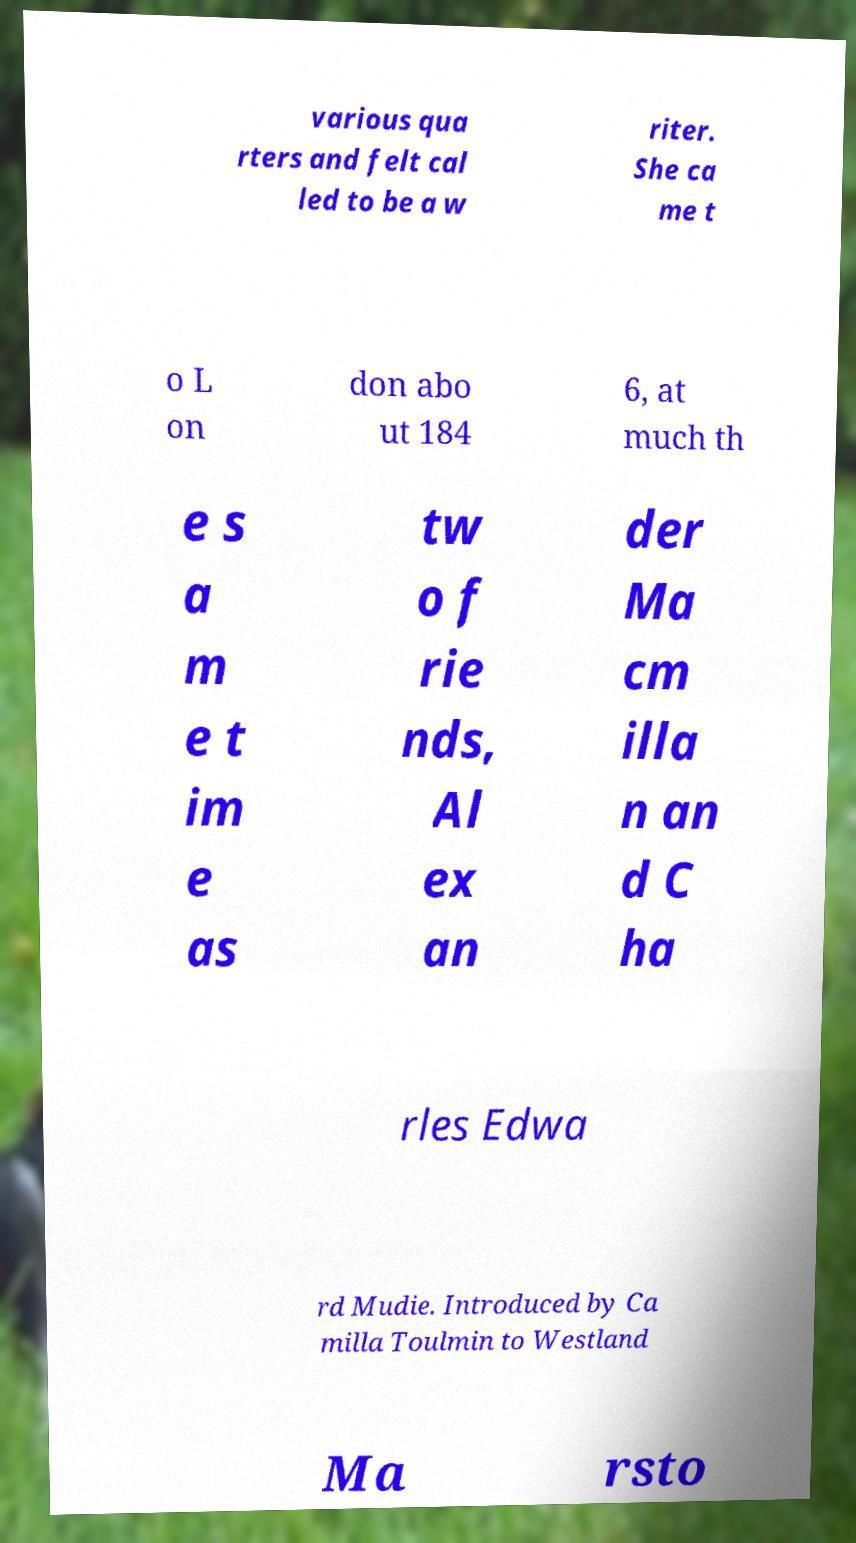Could you extract and type out the text from this image? various qua rters and felt cal led to be a w riter. She ca me t o L on don abo ut 184 6, at much th e s a m e t im e as tw o f rie nds, Al ex an der Ma cm illa n an d C ha rles Edwa rd Mudie. Introduced by Ca milla Toulmin to Westland Ma rsto 